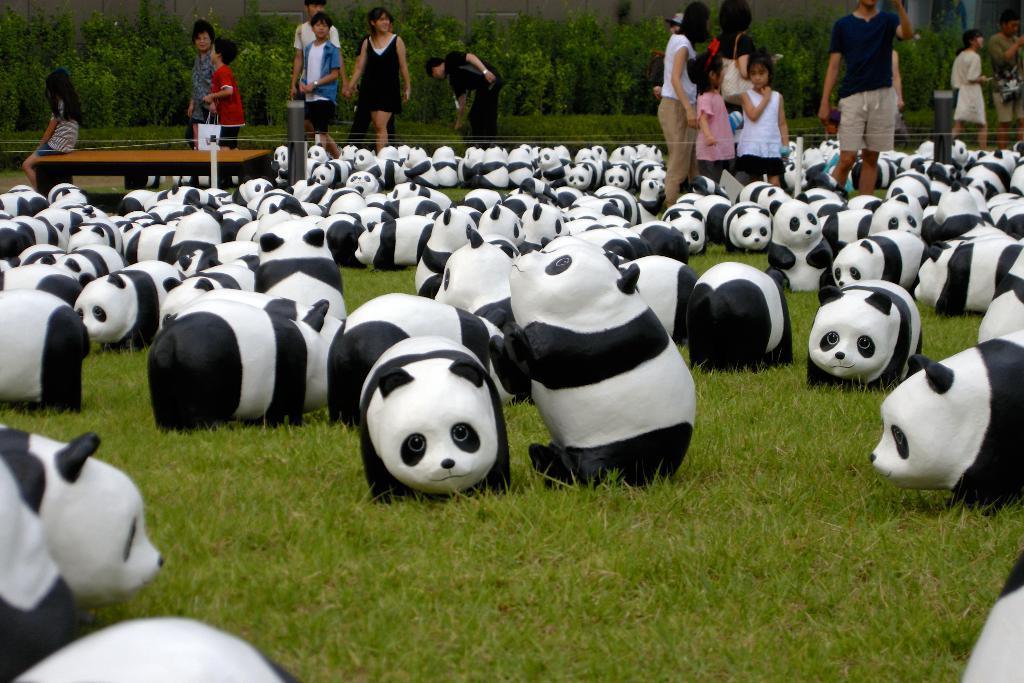Please provide a concise description of this image. In this image we can see there are toys on the ground and there are people standing on the ground and there is the other person sitting on the table and at the back we can see there are trees, grass and wall. 